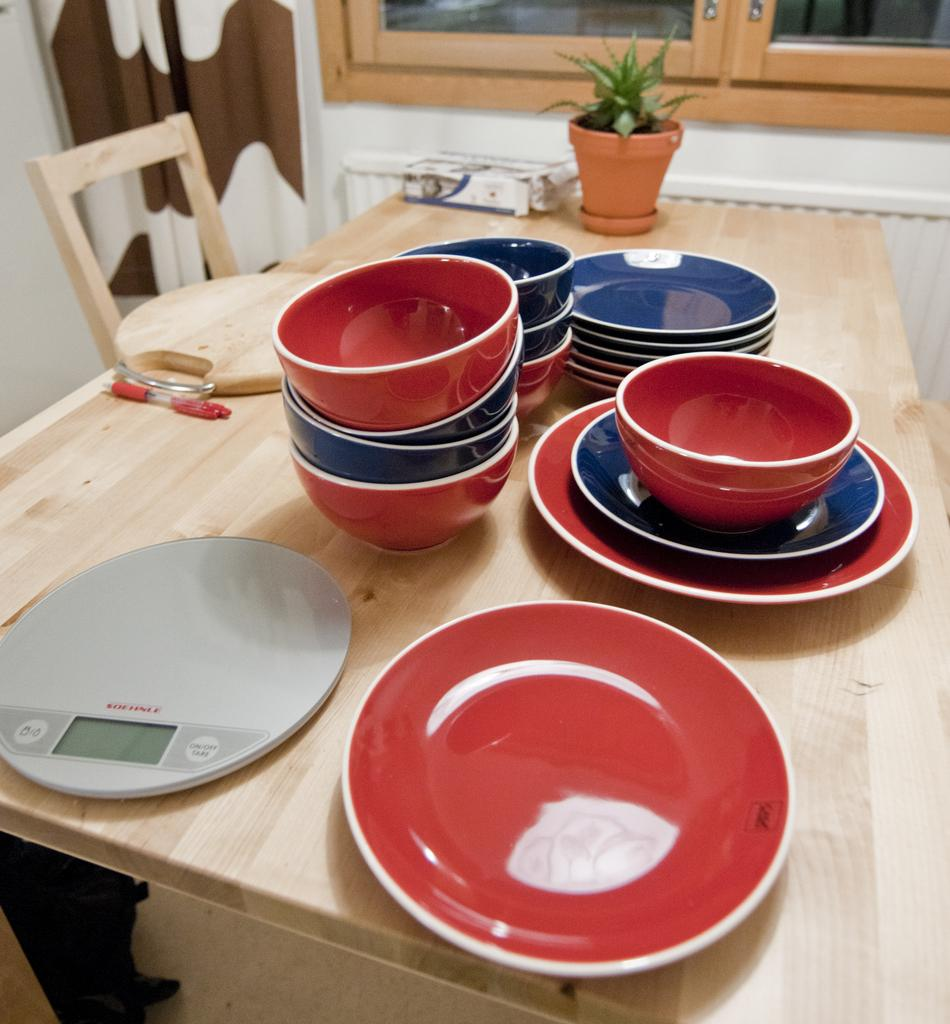<image>
Give a short and clear explanation of the subsequent image. The button on the right side of the scale is to turn it on 